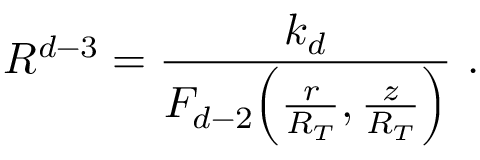Convert formula to latex. <formula><loc_0><loc_0><loc_500><loc_500>R ^ { d - 3 } = \frac { k _ { d } } { F _ { d - 2 } \left ( \frac { r } { R _ { T } } , \frac { z } { R _ { T } } \right ) } \ .</formula> 